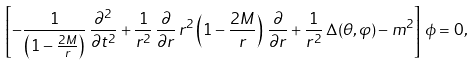<formula> <loc_0><loc_0><loc_500><loc_500>\left [ - \frac { 1 } { \left ( 1 - \frac { 2 M } { r } \right ) } \, \frac { \partial ^ { 2 } } { \partial t ^ { 2 } } + \frac { 1 } { r ^ { 2 } } \, \frac { \partial } { \partial r } \, r ^ { 2 } \left ( 1 - \frac { 2 M } { r } \right ) \, \frac { \partial } { \partial r } + \frac { 1 } { r ^ { 2 } } \, \Delta ( \theta , \varphi ) - m ^ { 2 } \right ] \, \phi = 0 ,</formula> 